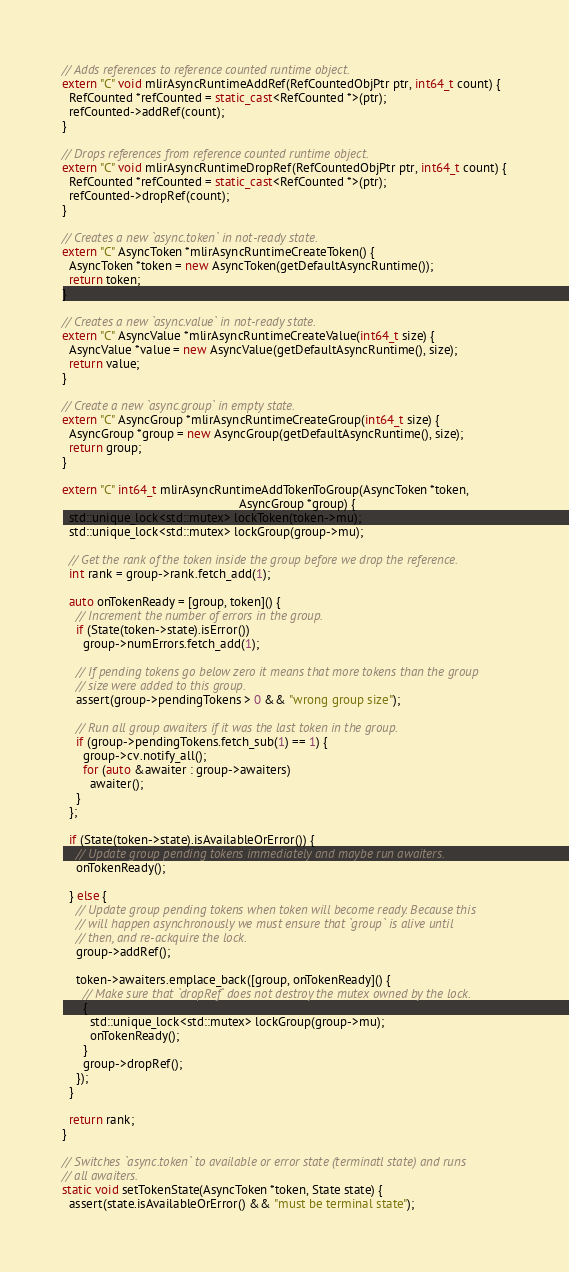Convert code to text. <code><loc_0><loc_0><loc_500><loc_500><_C++_>
// Adds references to reference counted runtime object.
extern "C" void mlirAsyncRuntimeAddRef(RefCountedObjPtr ptr, int64_t count) {
  RefCounted *refCounted = static_cast<RefCounted *>(ptr);
  refCounted->addRef(count);
}

// Drops references from reference counted runtime object.
extern "C" void mlirAsyncRuntimeDropRef(RefCountedObjPtr ptr, int64_t count) {
  RefCounted *refCounted = static_cast<RefCounted *>(ptr);
  refCounted->dropRef(count);
}

// Creates a new `async.token` in not-ready state.
extern "C" AsyncToken *mlirAsyncRuntimeCreateToken() {
  AsyncToken *token = new AsyncToken(getDefaultAsyncRuntime());
  return token;
}

// Creates a new `async.value` in not-ready state.
extern "C" AsyncValue *mlirAsyncRuntimeCreateValue(int64_t size) {
  AsyncValue *value = new AsyncValue(getDefaultAsyncRuntime(), size);
  return value;
}

// Create a new `async.group` in empty state.
extern "C" AsyncGroup *mlirAsyncRuntimeCreateGroup(int64_t size) {
  AsyncGroup *group = new AsyncGroup(getDefaultAsyncRuntime(), size);
  return group;
}

extern "C" int64_t mlirAsyncRuntimeAddTokenToGroup(AsyncToken *token,
                                                   AsyncGroup *group) {
  std::unique_lock<std::mutex> lockToken(token->mu);
  std::unique_lock<std::mutex> lockGroup(group->mu);

  // Get the rank of the token inside the group before we drop the reference.
  int rank = group->rank.fetch_add(1);

  auto onTokenReady = [group, token]() {
    // Increment the number of errors in the group.
    if (State(token->state).isError())
      group->numErrors.fetch_add(1);

    // If pending tokens go below zero it means that more tokens than the group
    // size were added to this group.
    assert(group->pendingTokens > 0 && "wrong group size");

    // Run all group awaiters if it was the last token in the group.
    if (group->pendingTokens.fetch_sub(1) == 1) {
      group->cv.notify_all();
      for (auto &awaiter : group->awaiters)
        awaiter();
    }
  };

  if (State(token->state).isAvailableOrError()) {
    // Update group pending tokens immediately and maybe run awaiters.
    onTokenReady();

  } else {
    // Update group pending tokens when token will become ready. Because this
    // will happen asynchronously we must ensure that `group` is alive until
    // then, and re-ackquire the lock.
    group->addRef();

    token->awaiters.emplace_back([group, onTokenReady]() {
      // Make sure that `dropRef` does not destroy the mutex owned by the lock.
      {
        std::unique_lock<std::mutex> lockGroup(group->mu);
        onTokenReady();
      }
      group->dropRef();
    });
  }

  return rank;
}

// Switches `async.token` to available or error state (terminatl state) and runs
// all awaiters.
static void setTokenState(AsyncToken *token, State state) {
  assert(state.isAvailableOrError() && "must be terminal state");</code> 